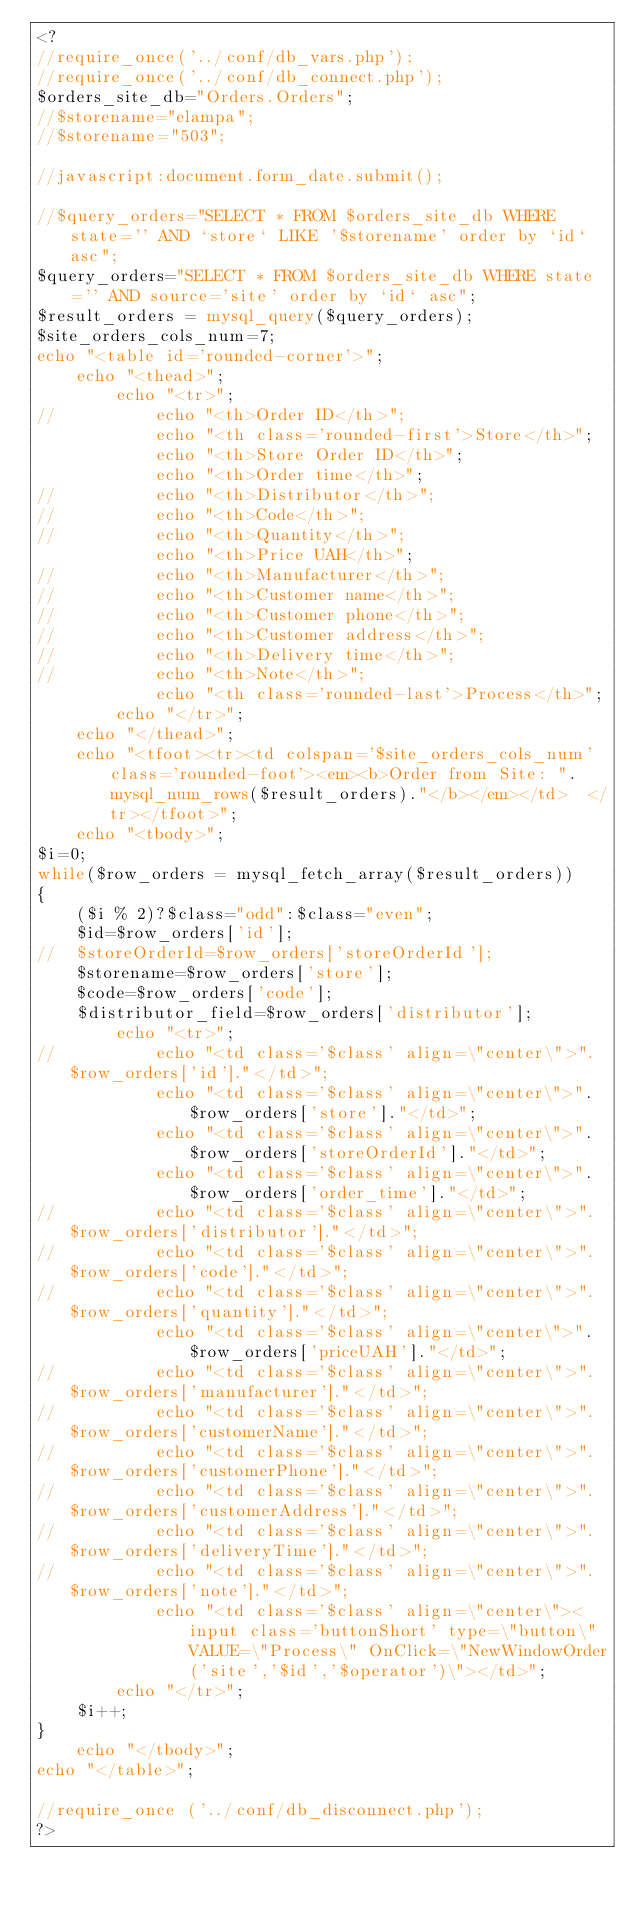Convert code to text. <code><loc_0><loc_0><loc_500><loc_500><_PHP_><?
//require_once('../conf/db_vars.php');
//require_once('../conf/db_connect.php');
$orders_site_db="Orders.Orders";
//$storename="elampa";
//$storename="503";

//javascript:document.form_date.submit();

//$query_orders="SELECT * FROM $orders_site_db WHERE state='' AND `store` LIKE '$storename' order by `id` asc";
$query_orders="SELECT * FROM $orders_site_db WHERE state='' AND source='site' order by `id` asc";
$result_orders = mysql_query($query_orders);
$site_orders_cols_num=7;
echo "<table id='rounded-corner'>";
	echo "<thead>";
		echo "<tr>";
//			echo "<th>Order ID</th>";
			echo "<th class='rounded-first'>Store</th>";
			echo "<th>Store Order ID</th>";
			echo "<th>Order time</th>";
//			echo "<th>Distributor</th>";
//			echo "<th>Code</th>";
//			echo "<th>Quantity</th>";
			echo "<th>Price UAH</th>";
//			echo "<th>Manufacturer</th>";
//			echo "<th>Customer name</th>";
//			echo "<th>Customer phone</th>";
//			echo "<th>Customer address</th>";
//			echo "<th>Delivery time</th>";
//			echo "<th>Note</th>";
			echo "<th class='rounded-last'>Process</th>";
		echo "</tr>";
	echo "</thead>";
	echo "<tfoot><tr><td colspan='$site_orders_cols_num' class='rounded-foot'><em><b>Order from Site: ".mysql_num_rows($result_orders)."</b></em></td>	</tr></tfoot>";
	echo "<tbody>";
$i=0;
while($row_orders = mysql_fetch_array($result_orders))
{
	($i % 2)?$class="odd":$class="even";
	$id=$row_orders['id'];
//	$storeOrderId=$row_orders['storeOrderId'];
	$storename=$row_orders['store'];
	$code=$row_orders['code'];
	$distributor_field=$row_orders['distributor'];
		echo "<tr>";
//			echo "<td class='$class' align=\"center\">".$row_orders['id']."</td>";
			echo "<td class='$class' align=\"center\">".$row_orders['store']."</td>";
			echo "<td class='$class' align=\"center\">".$row_orders['storeOrderId']."</td>";
			echo "<td class='$class' align=\"center\">".$row_orders['order_time']."</td>";
//			echo "<td class='$class' align=\"center\">".$row_orders['distributor']."</td>";
//			echo "<td class='$class' align=\"center\">".$row_orders['code']."</td>";
//			echo "<td class='$class' align=\"center\">".$row_orders['quantity']."</td>";
			echo "<td class='$class' align=\"center\">".$row_orders['priceUAH']."</td>";
//			echo "<td class='$class' align=\"center\">".$row_orders['manufacturer']."</td>";
//			echo "<td class='$class' align=\"center\">".$row_orders['customerName']."</td>";
//			echo "<td class='$class' align=\"center\">".$row_orders['customerPhone']."</td>";
//			echo "<td class='$class' align=\"center\">".$row_orders['customerAddress']."</td>";
//			echo "<td class='$class' align=\"center\">".$row_orders['deliveryTime']."</td>";
//			echo "<td class='$class' align=\"center\">".$row_orders['note']."</td>";
			echo "<td class='$class' align=\"center\"><input class='buttonShort' type=\"button\" VALUE=\"Process\" OnClick=\"NewWindowOrder('site','$id','$operator')\"></td>";
		echo "</tr>";
	$i++;
}
	echo "</tbody>";
echo "</table>";

//require_once ('../conf/db_disconnect.php');
?>
</code> 